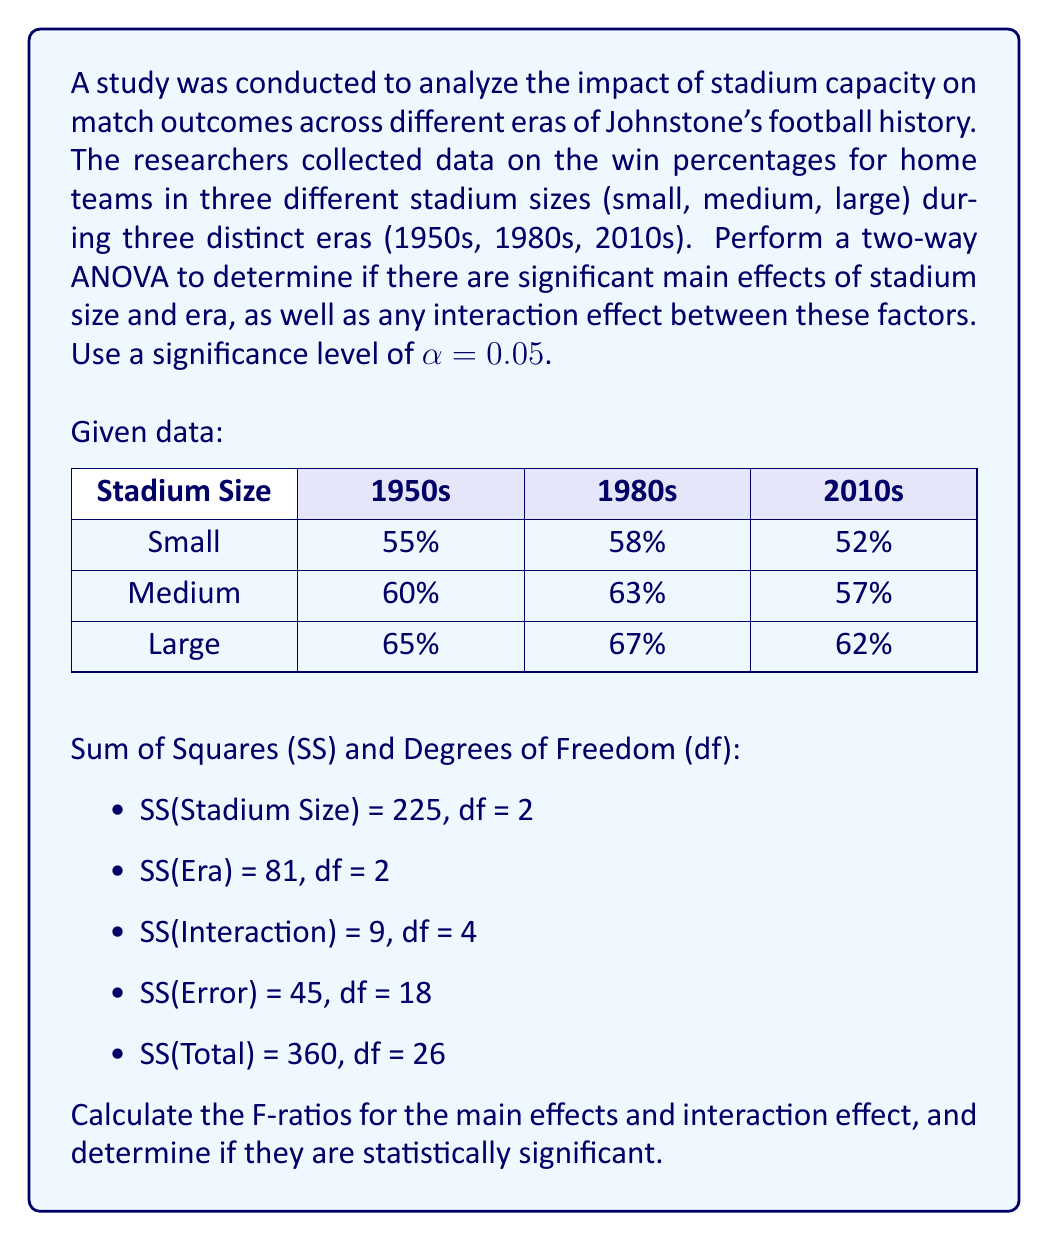Help me with this question. To perform a two-way ANOVA, we need to calculate the Mean Square (MS) values and F-ratios for each effect, then compare them to the critical F-value.

Step 1: Calculate MS values
MS = SS / df

MS(Stadium Size) = 225 / 2 = 112.5
MS(Era) = 81 / 2 = 40.5
MS(Interaction) = 9 / 4 = 2.25
MS(Error) = 45 / 18 = 2.5

Step 2: Calculate F-ratios
F-ratio = MS(effect) / MS(Error)

F(Stadium Size) = 112.5 / 2.5 = 45
F(Era) = 40.5 / 2.5 = 16.2
F(Interaction) = 2.25 / 2.5 = 0.9

Step 3: Determine critical F-values
For α = 0.05:
F(critical) for Stadium Size and Era: F(2, 18) ≈ 3.55
F(critical) for Interaction: F(4, 18) ≈ 2.93

Step 4: Compare F-ratios to critical F-values

Stadium Size: F(2, 18) = 45 > 3.55
Era: F(2, 18) = 16.2 > 3.55
Interaction: F(4, 18) = 0.9 < 2.93

Step 5: Interpret results

The main effect of Stadium Size is statistically significant (F = 45, p < 0.05).
The main effect of Era is statistically significant (F = 16.2, p < 0.05).
The interaction effect between Stadium Size and Era is not statistically significant (F = 0.9, p > 0.05).
Answer: The two-way ANOVA results show:
1. Significant main effect of Stadium Size: F(2, 18) = 45, p < 0.05
2. Significant main effect of Era: F(2, 18) = 16.2, p < 0.05
3. No significant interaction effect: F(4, 18) = 0.9, p > 0.05

Stadium size and era independently affect match outcomes, but there is no significant interaction between these factors. 